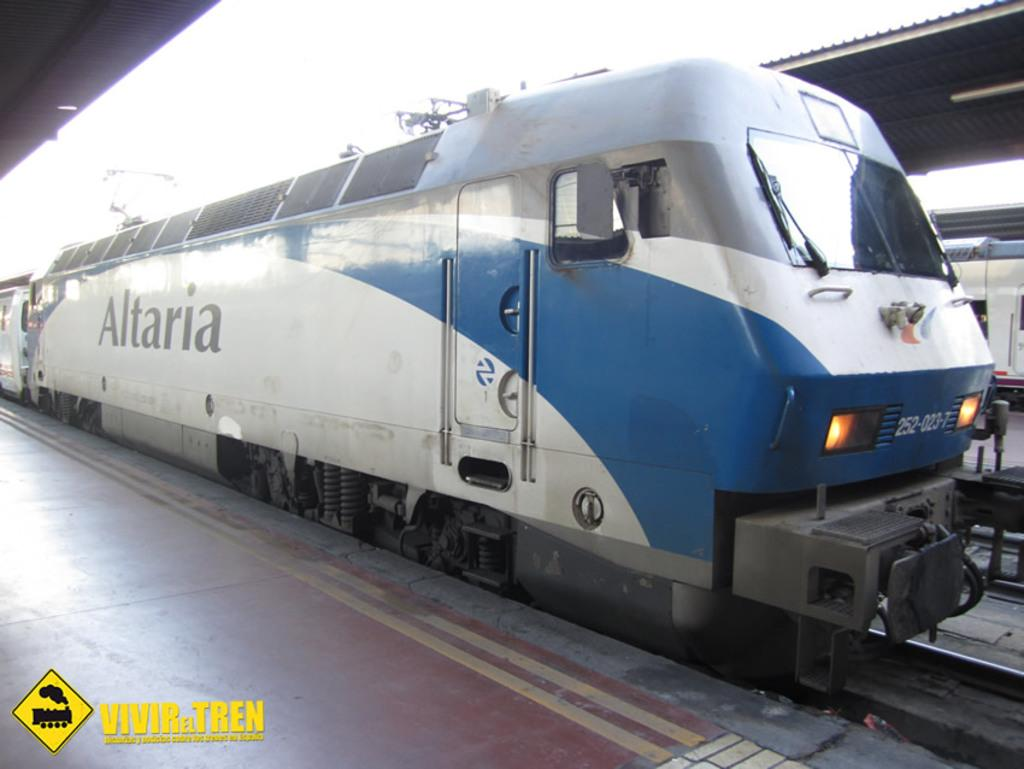What can be seen traveling on the tracks in the image? There are trains on the tracks in the image. What type of structures are present in the image? There are sheds in the image. Where is the watermark located in the image? The watermark is at the left bottom of the image. What brand or organization might be associated with the image? There is a logo in the image, which could indicate the brand or organization. Can you see a tiger kicking a soccer ball in the image? No, there is no tiger or soccer ball present in the image. 